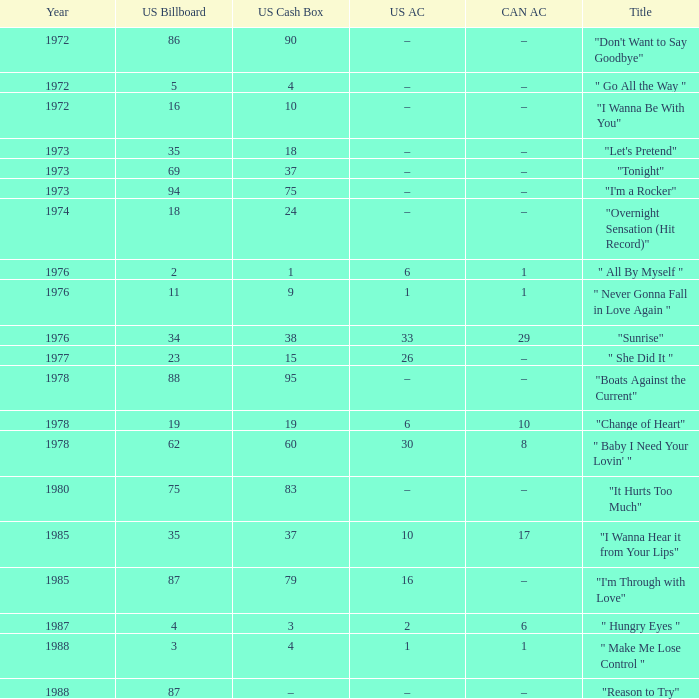What is the US cash box before 1978 with a US billboard of 35? 18.0. 